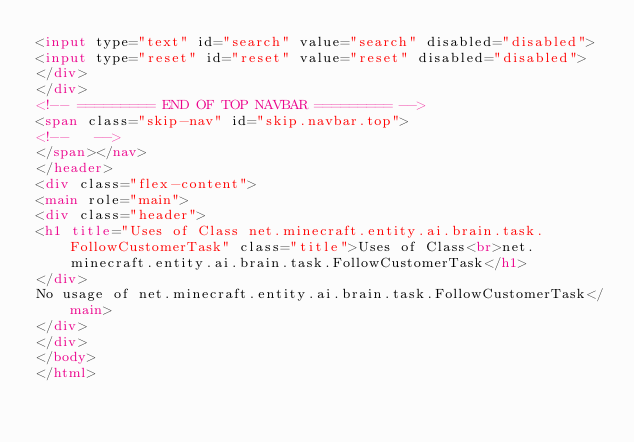Convert code to text. <code><loc_0><loc_0><loc_500><loc_500><_HTML_><input type="text" id="search" value="search" disabled="disabled">
<input type="reset" id="reset" value="reset" disabled="disabled">
</div>
</div>
<!-- ========= END OF TOP NAVBAR ========= -->
<span class="skip-nav" id="skip.navbar.top">
<!--   -->
</span></nav>
</header>
<div class="flex-content">
<main role="main">
<div class="header">
<h1 title="Uses of Class net.minecraft.entity.ai.brain.task.FollowCustomerTask" class="title">Uses of Class<br>net.minecraft.entity.ai.brain.task.FollowCustomerTask</h1>
</div>
No usage of net.minecraft.entity.ai.brain.task.FollowCustomerTask</main>
</div>
</div>
</body>
</html>
</code> 